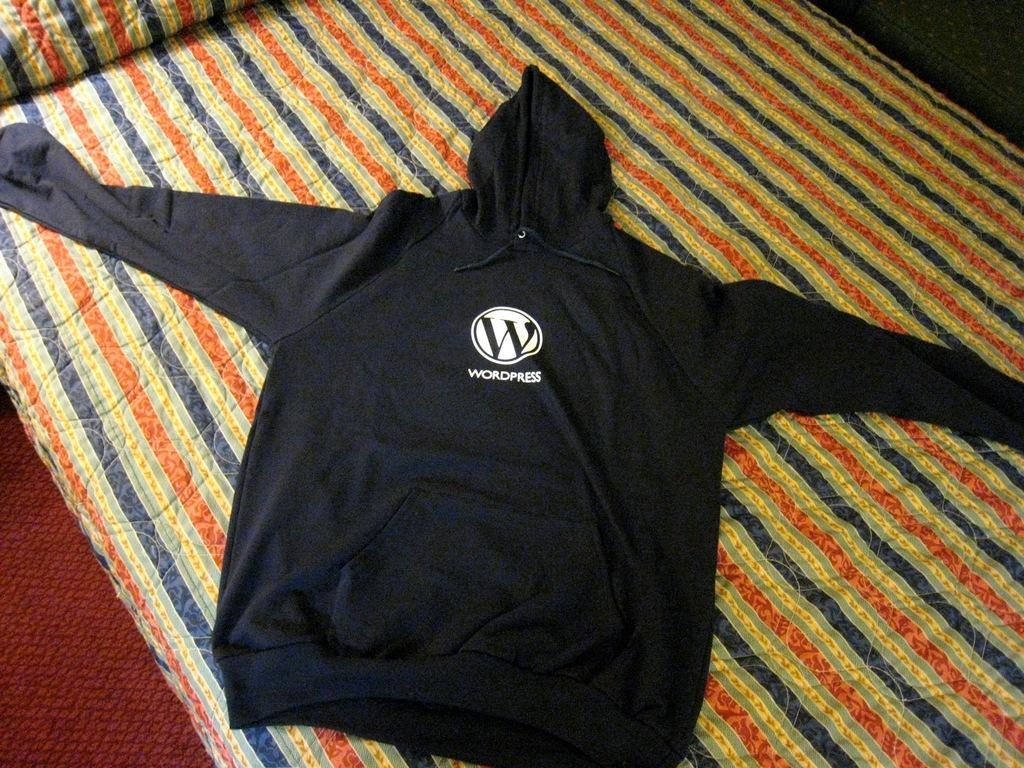What is placed on the blanket in the image? There is a hoodie on a blanket in the image. What type of flooring can be seen on the left side of the image? There appears to be a carpet on the left side of the image. What type of magic is being performed with the hoodie in the image? There is no magic or any indication of a magical performance in the image; it simply shows a hoodie on a blanket. 